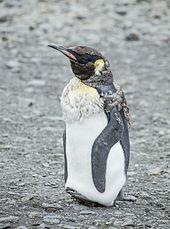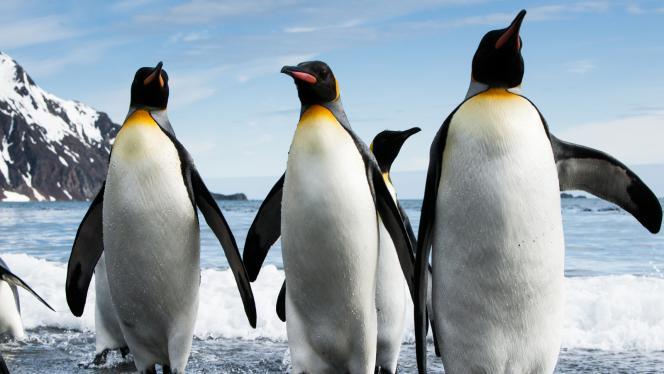The first image is the image on the left, the second image is the image on the right. For the images shown, is this caption "A total of two penguins are on both images." true? Answer yes or no. No. 